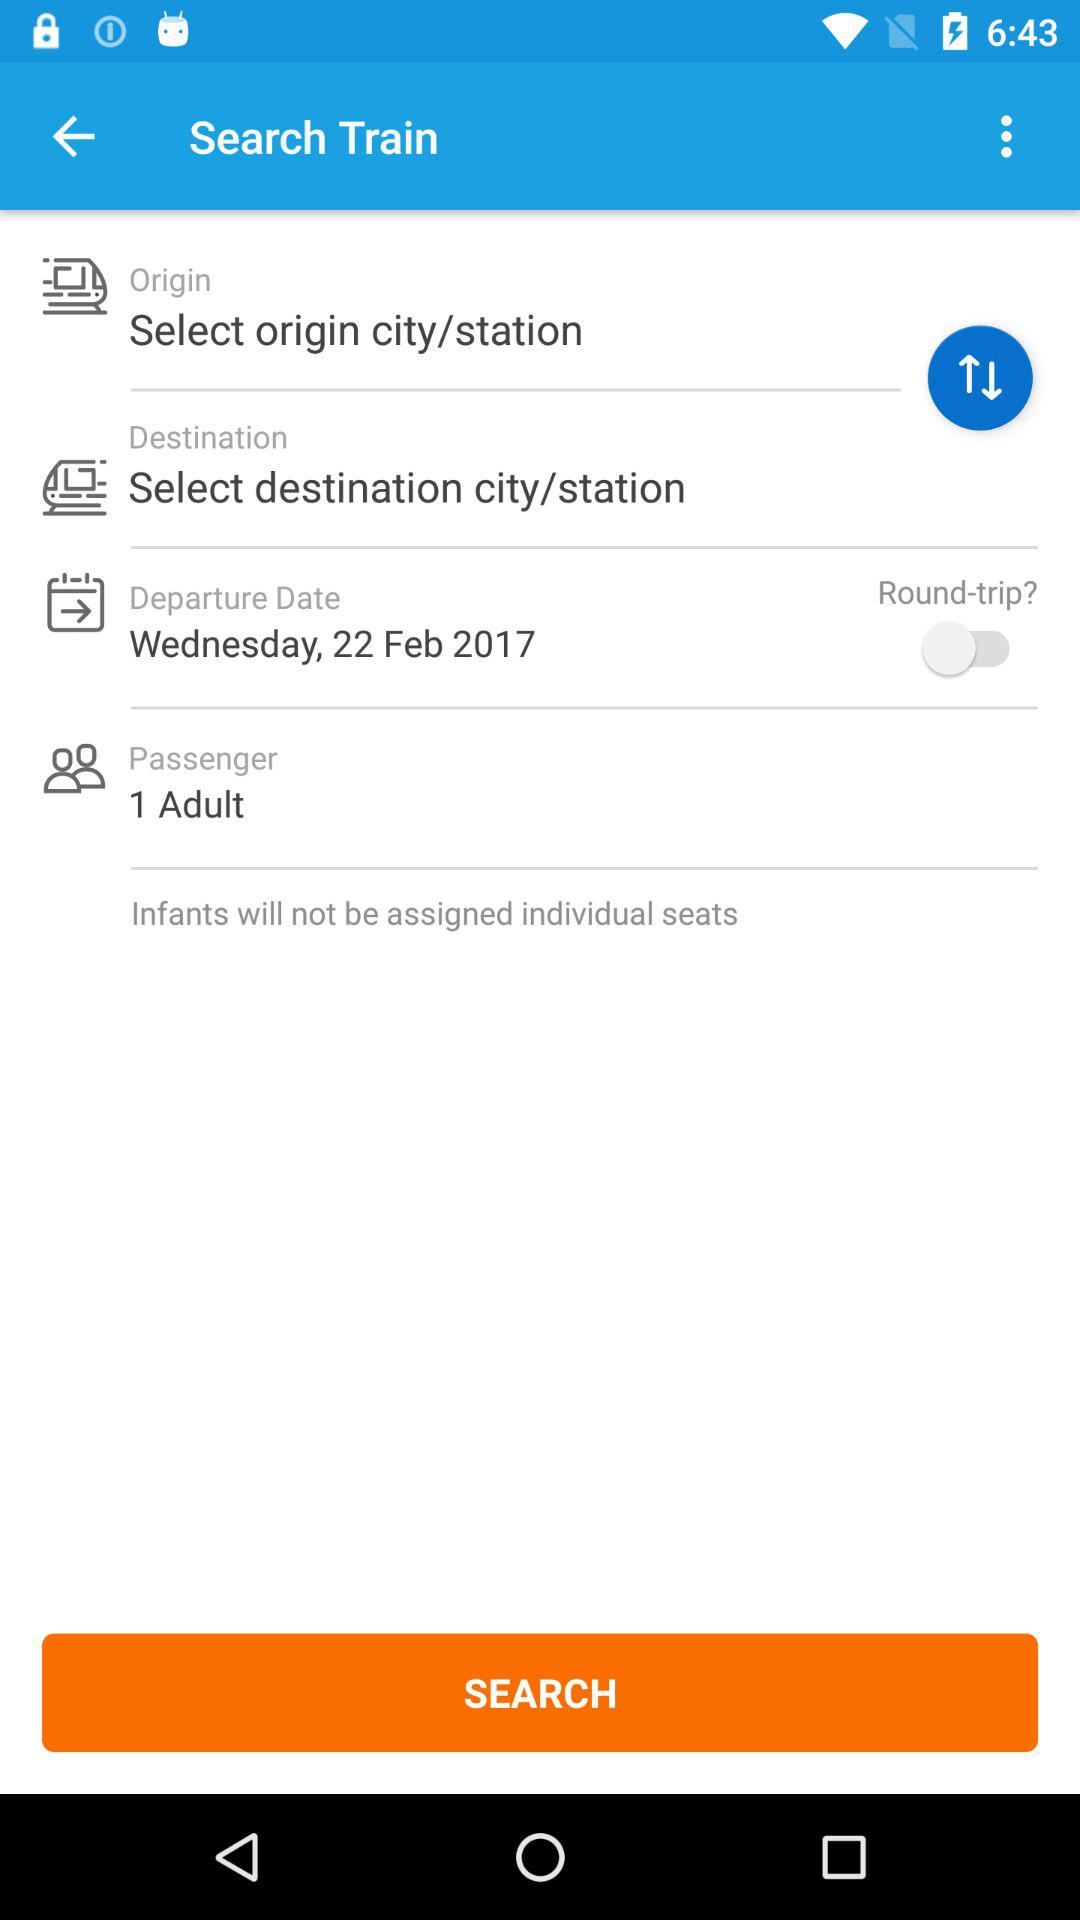What is the departure date? The departure date is Wednesday, February 22, 2017. 